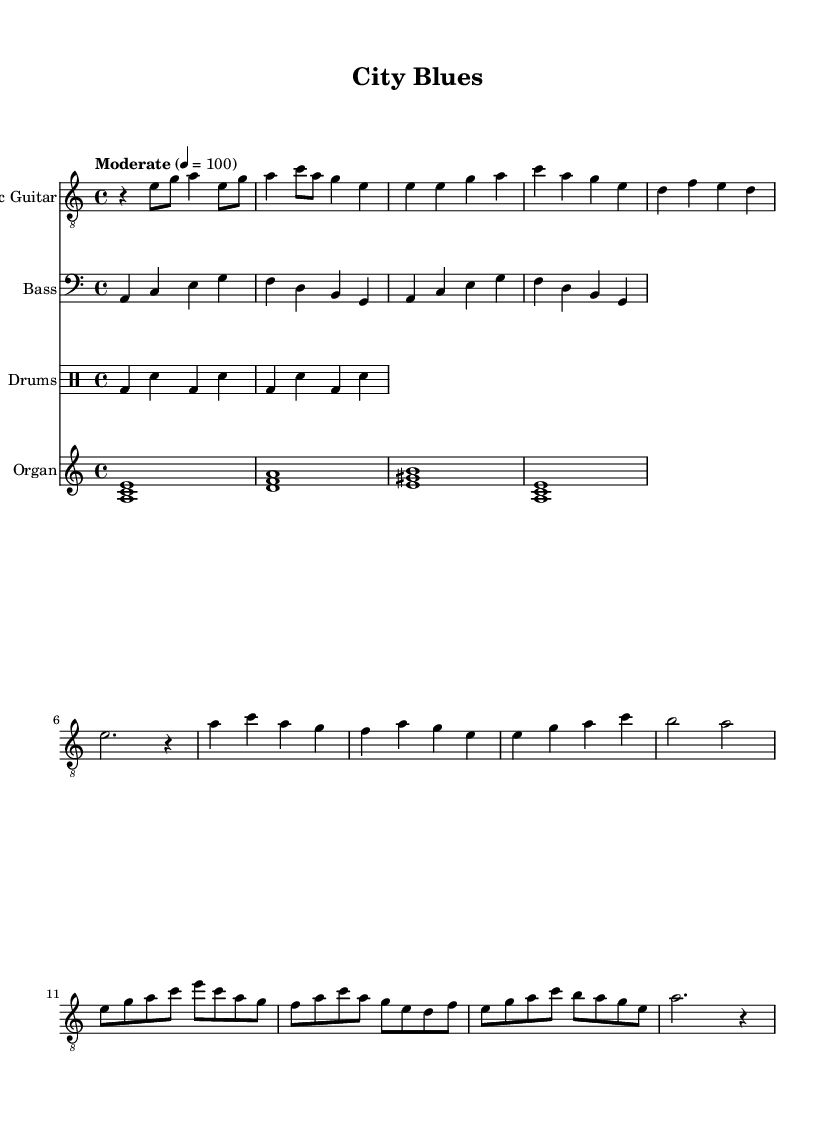What is the key signature of this music? The key signature is identified by the "key a minor" command at the start of the global block. A minor has one sharp, which corresponds to G sharp in the scale.
Answer: A minor What is the time signature of the piece? The time signature is specified by the "time 4/4" command in the global block. This indicates that there are four beats in every measure, and the quarter note gets one beat.
Answer: 4/4 What is the tempo marking for this piece? The tempo marking is indicated by "tempo Moderate 4 = 100" in the global block. This means the piece should be played at a moderate speed of 100 beats per minute.
Answer: Moderate 100 How many measures are in the intro for the electric guitar? The intro consists of two measures, as represented by the guitar riff notation at the beginning of the electric guitar part, which contains two sets of rhythmic elements.
Answer: 2 Which instrument has a walking bass line? The bass part is notated below the electric guitar, and the note arrangement reflects a walking bass line, characterized by a steady quarter note rhythm that moves between anchored notes.
Answer: Bass What chord is played by the organ in the first measure? The organ plays the chord <a c e> in the first measure, as shown in the organ part notation, indicating an A minor chord.
Answer: A minor What type of rhythm pattern is used in the drums part? The drum part consists of a basic rhythm pattern denoted as a sequence of bass drum and snare hits, specifically alternating in a four-beat structure typical for blues music.
Answer: Basic drum pattern 